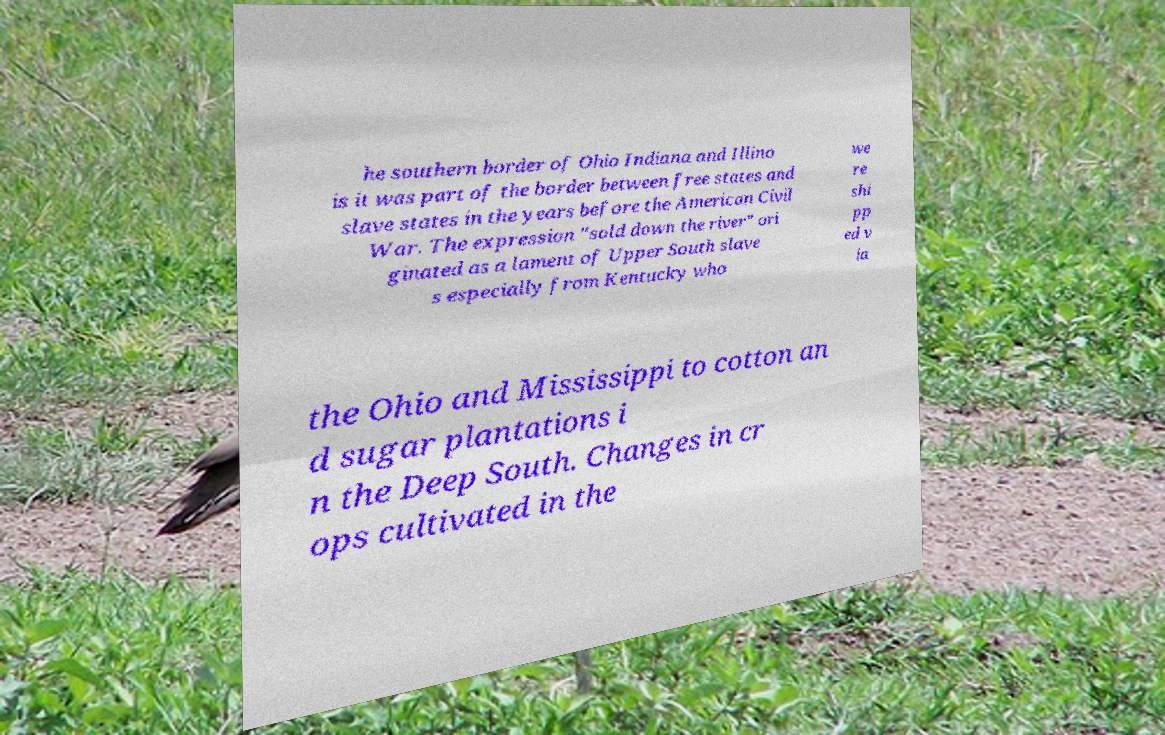Can you read and provide the text displayed in the image?This photo seems to have some interesting text. Can you extract and type it out for me? he southern border of Ohio Indiana and Illino is it was part of the border between free states and slave states in the years before the American Civil War. The expression "sold down the river" ori ginated as a lament of Upper South slave s especially from Kentucky who we re shi pp ed v ia the Ohio and Mississippi to cotton an d sugar plantations i n the Deep South. Changes in cr ops cultivated in the 